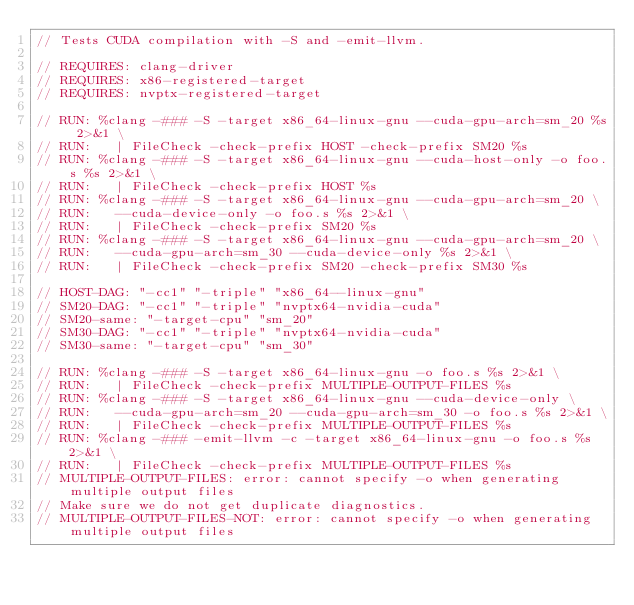<code> <loc_0><loc_0><loc_500><loc_500><_Cuda_>// Tests CUDA compilation with -S and -emit-llvm.

// REQUIRES: clang-driver
// REQUIRES: x86-registered-target
// REQUIRES: nvptx-registered-target

// RUN: %clang -### -S -target x86_64-linux-gnu --cuda-gpu-arch=sm_20 %s 2>&1 \
// RUN:   | FileCheck -check-prefix HOST -check-prefix SM20 %s
// RUN: %clang -### -S -target x86_64-linux-gnu --cuda-host-only -o foo.s %s 2>&1 \
// RUN:   | FileCheck -check-prefix HOST %s
// RUN: %clang -### -S -target x86_64-linux-gnu --cuda-gpu-arch=sm_20 \
// RUN:   --cuda-device-only -o foo.s %s 2>&1 \
// RUN:   | FileCheck -check-prefix SM20 %s
// RUN: %clang -### -S -target x86_64-linux-gnu --cuda-gpu-arch=sm_20 \
// RUN:   --cuda-gpu-arch=sm_30 --cuda-device-only %s 2>&1 \
// RUN:   | FileCheck -check-prefix SM20 -check-prefix SM30 %s

// HOST-DAG: "-cc1" "-triple" "x86_64--linux-gnu"
// SM20-DAG: "-cc1" "-triple" "nvptx64-nvidia-cuda"
// SM20-same: "-target-cpu" "sm_20"
// SM30-DAG: "-cc1" "-triple" "nvptx64-nvidia-cuda"
// SM30-same: "-target-cpu" "sm_30"

// RUN: %clang -### -S -target x86_64-linux-gnu -o foo.s %s 2>&1 \
// RUN:   | FileCheck -check-prefix MULTIPLE-OUTPUT-FILES %s
// RUN: %clang -### -S -target x86_64-linux-gnu --cuda-device-only \
// RUN:   --cuda-gpu-arch=sm_20 --cuda-gpu-arch=sm_30 -o foo.s %s 2>&1 \
// RUN:   | FileCheck -check-prefix MULTIPLE-OUTPUT-FILES %s
// RUN: %clang -### -emit-llvm -c -target x86_64-linux-gnu -o foo.s %s 2>&1 \
// RUN:   | FileCheck -check-prefix MULTIPLE-OUTPUT-FILES %s
// MULTIPLE-OUTPUT-FILES: error: cannot specify -o when generating multiple output files
// Make sure we do not get duplicate diagnostics.
// MULTIPLE-OUTPUT-FILES-NOT: error: cannot specify -o when generating multiple output files
</code> 